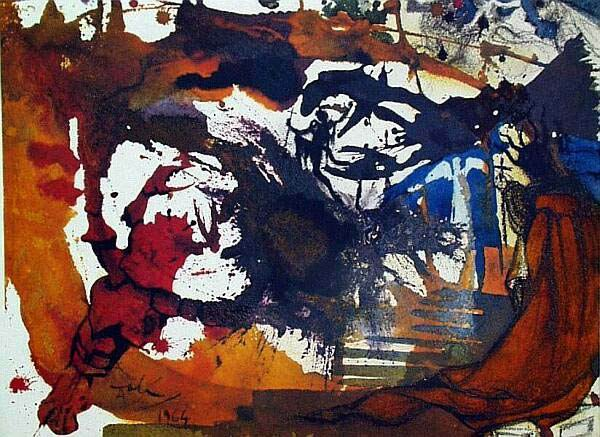Create a detailed story that could be inspired by this artwork. In a distant realm where emotion dictates the landscape, a once vibrant and peaceful kingdom now finds itself embroiled in a storm of turmoil. The kingdom's guardian, an artist of unparalleled skill, has painted a masterpiece imbued with life and emotion. As they wield their brush, each stroke echoes the kingdom's escalating chaos. The reds rage in ferocious conflict, while blues whisper melancholic tales of loss and longing. Amid the swirling tempest of colors, figures emerge and disperse, representing the fractured souls that once thrived in harmony. This painting is more than mere art; it is the heartbeat of the kingdom, now pulsing with the anguish of its people. The guardian, overwhelmed by the immense responsibility, pours their heart into the canvas, hoping to restore balance and peace through the evocative power of their creation. Can you place the artwork in a day-to-day realistic scenario? Certainly, imagine walking into a bustling modern art gallery in a city like New York. Amidst the eclectic collection of contemporary works, this piece stands out on a large white wall. Its vibrant, chaotic composition catches the eye of every passerby, often compelling them to stop and contemplate its meaning. As you gaze at it, you overhear various interpretations from other gallery visitors—some see it as a reflection of modern life's chaos, while others draw personal connections to its tumultuous energy. The gallery setting amplifies the painting's impact, fostering a shared space for diverse emotional and intellectual engagement. What might be the artist's thoughts while creating this piece? The artist, standing in front of a large canvas with a palette of rich, vibrant colors at their disposal, might have been in a deeply introspective state. Each brushstroke is deliberate yet spontaneous, driven by a whirlwind of emotions. As the colors mix and clash on the canvas, the artist reflects on their personal experiences and internal conflicts. There's a sense of urgency in their movements, a need to externalize what lies within. They contemplate themes of chaos and order, passion and solitude, seeking to balance these opposing forces through their art. The process is cathartic, a meditative act of pouring one's soul onto the canvas, hoping that it resonates with and evokes a response in others. 